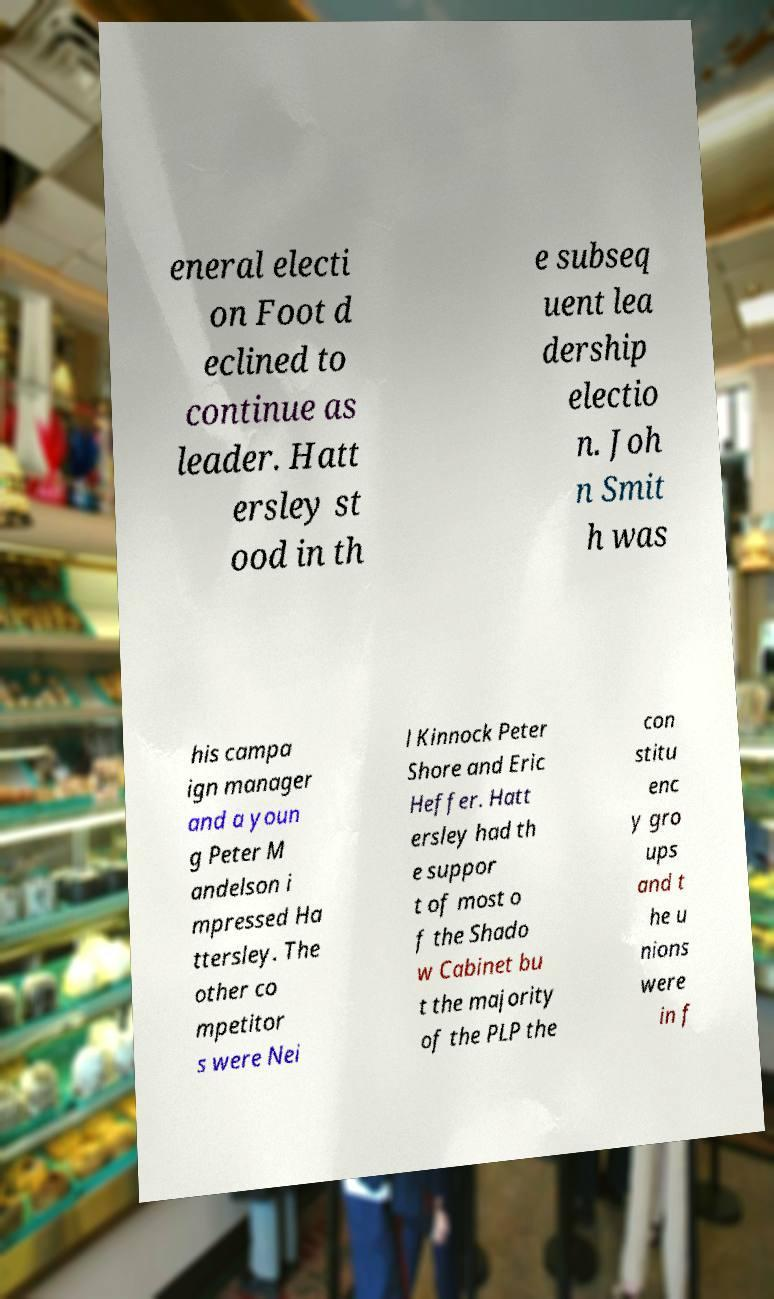There's text embedded in this image that I need extracted. Can you transcribe it verbatim? eneral electi on Foot d eclined to continue as leader. Hatt ersley st ood in th e subseq uent lea dership electio n. Joh n Smit h was his campa ign manager and a youn g Peter M andelson i mpressed Ha ttersley. The other co mpetitor s were Nei l Kinnock Peter Shore and Eric Heffer. Hatt ersley had th e suppor t of most o f the Shado w Cabinet bu t the majority of the PLP the con stitu enc y gro ups and t he u nions were in f 